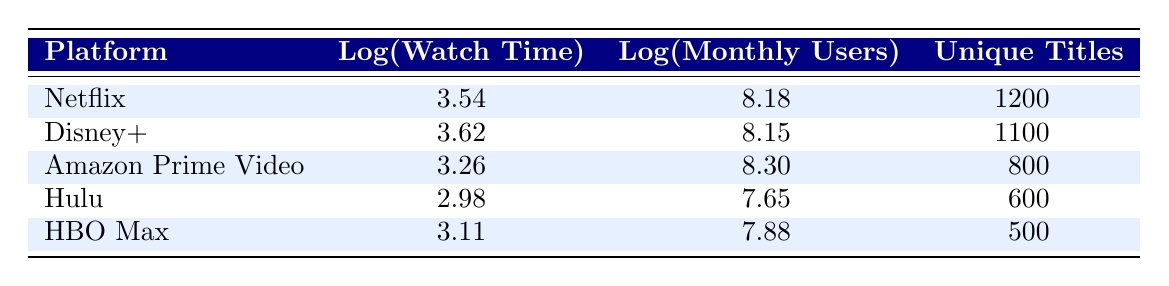What is the watch time in hours for Netflix? The table shows that the watch time for Netflix is 3500 hours.
Answer: 3500 hours Which platform has the most monthly active users? According to the table, Amazon Prime Video has the highest monthly active users at 200,000,000.
Answer: Amazon Prime Video What is the unique title count for Hulu? From the table, Hulu has a unique title count of 600.
Answer: 600 Which platform has the lowest watch time and how much is it? The platform with the lowest watch time is Hulu, with 950 hours.
Answer: Hulu, 950 hours What is the average watch time for Kids & Family content across all platforms? The total watch time is 3500 + 4200 + 1800 + 950 + 1300 = 12050 hours. There are 5 platforms, so the average watch time is 12050 / 5 = 2410 hours.
Answer: 2410 hours Is the unique title count for Disney+ greater than that of HBO Max? Disney+ has 1100 unique titles, while HBO Max has 500. Since 1100 is greater than 500, the answer is yes.
Answer: Yes How does the watch time of Amazon Prime Video compare to that of Netflix? Netflix has 3500 hours, and Amazon Prime Video has 1800 hours. Since 3500 is greater than 1800, Netflix has more watch time than Amazon Prime Video.
Answer: Netflix has more watch time What is the total number of unique titles across all platforms? The total number of unique titles is 1200 + 1100 + 800 + 600 + 500 = 4200 titles.
Answer: 4200 titles Which platform has the highest logarithmic value for watch time? The logarithmic value for Netflix is 3.54, for Disney+ 3.62, for Amazon Prime Video 3.26, for Hulu 2.98, and for HBO Max 3.11. The highest is 3.62 for Disney+.
Answer: Disney+ 